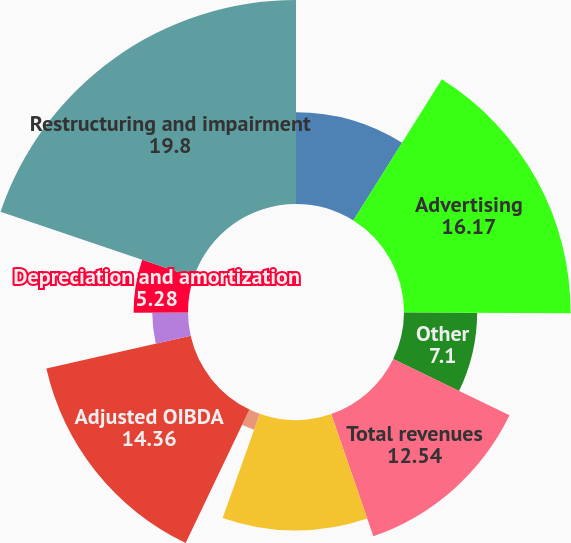<chart> <loc_0><loc_0><loc_500><loc_500><pie_chart><fcel>Distribution<fcel>Advertising<fcel>Other<fcel>Total revenues<fcel>Selling general and<fcel>Add Amortization of deferred<fcel>Adjusted OIBDA<fcel>Amortization of deferred<fcel>Depreciation and amortization<fcel>Restructuring and impairment<nl><fcel>8.91%<fcel>16.17%<fcel>7.1%<fcel>12.54%<fcel>10.73%<fcel>1.65%<fcel>14.36%<fcel>3.47%<fcel>5.28%<fcel>19.8%<nl></chart> 